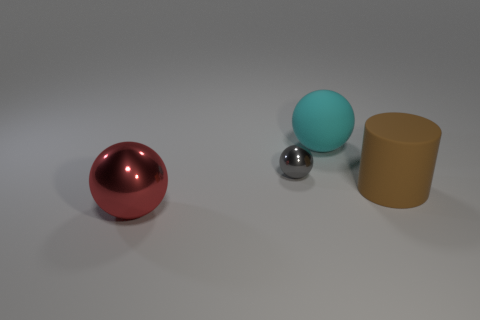Does the metallic object that is to the right of the red shiny thing have the same size as the cyan matte thing?
Provide a short and direct response. No. What color is the metal ball that is to the right of the big red metal sphere?
Offer a terse response. Gray. What number of brown matte spheres are there?
Your answer should be compact. 0. There is another large object that is the same material as the cyan thing; what is its shape?
Make the answer very short. Cylinder. Does the large ball that is in front of the cyan ball have the same color as the shiny sphere that is to the right of the red thing?
Make the answer very short. No. Are there an equal number of brown things that are in front of the large red object and small brown metal things?
Your answer should be compact. Yes. How many metal spheres are in front of the tiny sphere?
Your answer should be very brief. 1. The brown cylinder is what size?
Ensure brevity in your answer.  Large. What is the color of the object that is the same material as the cylinder?
Your response must be concise. Cyan. What number of red spheres are the same size as the rubber cylinder?
Provide a succinct answer. 1. 